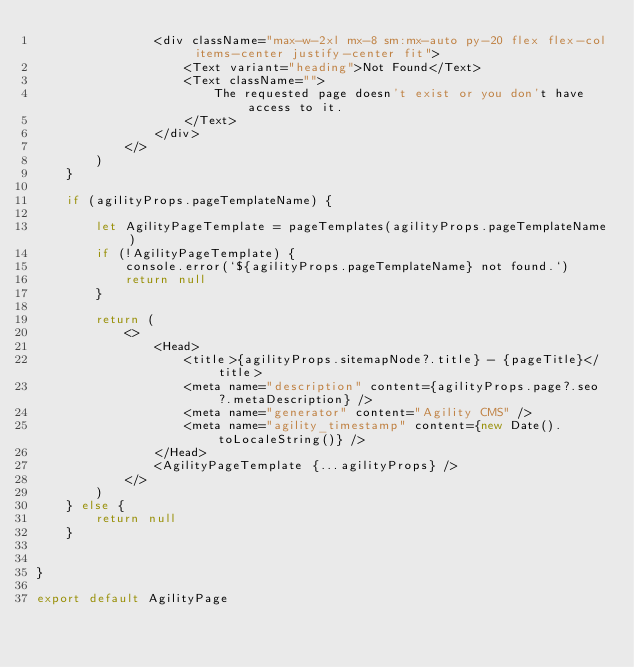<code> <loc_0><loc_0><loc_500><loc_500><_TypeScript_>				<div className="max-w-2xl mx-8 sm:mx-auto py-20 flex flex-col items-center justify-center fit">
					<Text variant="heading">Not Found</Text>
					<Text className="">
						The requested page doesn't exist or you don't have access to it.
					</Text>
				</div>
			</>
		)
	}

	if (agilityProps.pageTemplateName) {

		let AgilityPageTemplate = pageTemplates(agilityProps.pageTemplateName)
		if (!AgilityPageTemplate) {
			console.error(`${agilityProps.pageTemplateName} not found.`)
			return null
		}

		return (
			<>
				<Head>
					<title>{agilityProps.sitemapNode?.title} - {pageTitle}</title>
					<meta name="description" content={agilityProps.page?.seo?.metaDescription} />
					<meta name="generator" content="Agility CMS" />
					<meta name="agility_timestamp" content={new Date().toLocaleString()} />
				</Head>
				<AgilityPageTemplate {...agilityProps} />
			</>
		)
	} else {
		return null
	}


}

export default AgilityPage</code> 